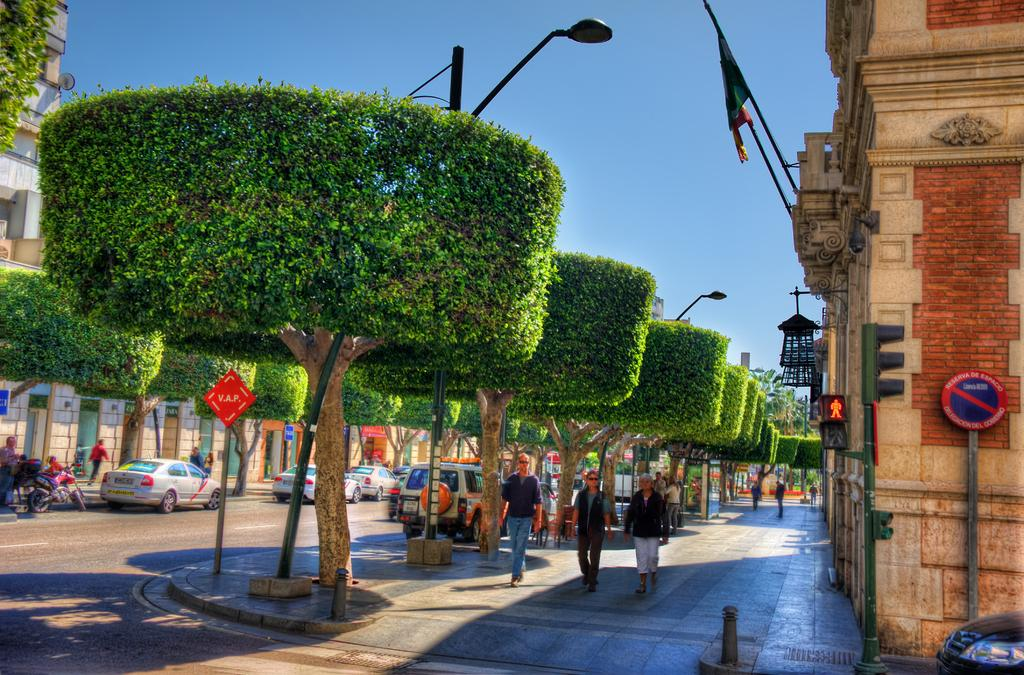Who or what can be seen in the image? There are people in the image. What type of structures are visible in the image? There are buildings in the image. What might provide information or directions in the image? Sign boards are present in the image. What might provide illumination at night in the image? Light poles are visible in the image. What type of transportation can be seen in the image? Vehicles are in the image, including a motorcycle on the road. What type of vegetation is present in the image? Trees are present in the image. What part of the natural environment is visible in the image? The sky is visible in the image. Can you tell me how many credit cards are being used by the people in the image? There is no information about credit cards or their usage in the image; it only shows people, buildings, sign boards, light poles, vehicles, a motorcycle, trees, and the sky. 